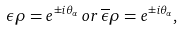<formula> <loc_0><loc_0><loc_500><loc_500>\epsilon \rho = e ^ { \pm i \theta _ { \alpha } } \, o r \, \overline { \epsilon } \rho = e ^ { \pm i \theta _ { \alpha } } ,</formula> 